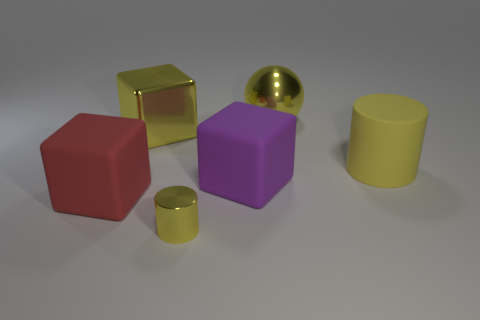Does the small object have the same shape as the rubber object that is to the right of the yellow shiny ball?
Your response must be concise. Yes. There is another yellow object that is the same shape as the big yellow matte thing; what size is it?
Keep it short and to the point. Small. There is a ball that is the same color as the large cylinder; what material is it?
Offer a terse response. Metal. What size is the metallic cylinder that is the same color as the large ball?
Provide a succinct answer. Small. What size is the cylinder that is in front of the big cube that is to the left of the large yellow cube?
Your answer should be compact. Small. What number of large purple cylinders are made of the same material as the tiny thing?
Keep it short and to the point. 0. Are there any large red rubber blocks?
Keep it short and to the point. Yes. There is a block that is behind the yellow rubber cylinder; how big is it?
Keep it short and to the point. Large. How many metallic objects are the same color as the big shiny block?
Your answer should be compact. 2. What number of spheres are either small yellow objects or purple rubber objects?
Make the answer very short. 0. 